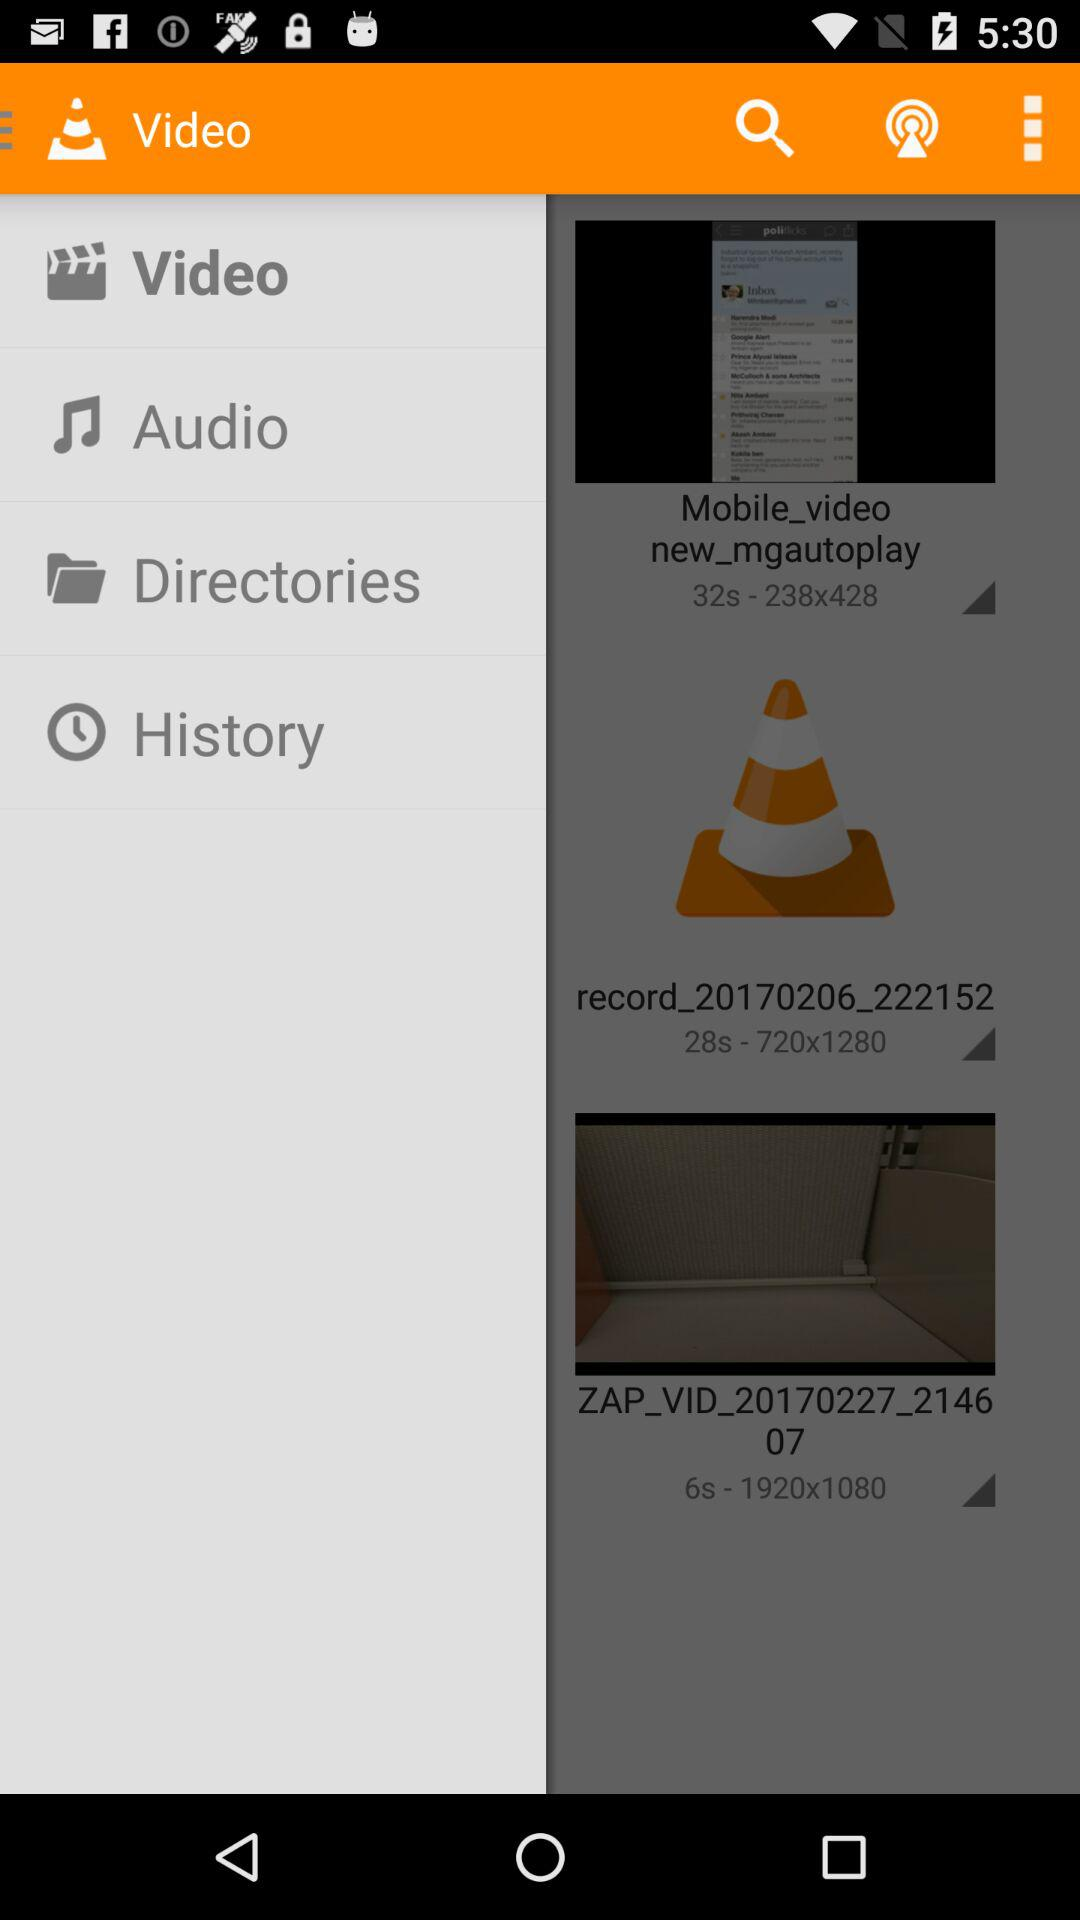How many items have a gray triangle with a shadow?
Answer the question using a single word or phrase. 3 